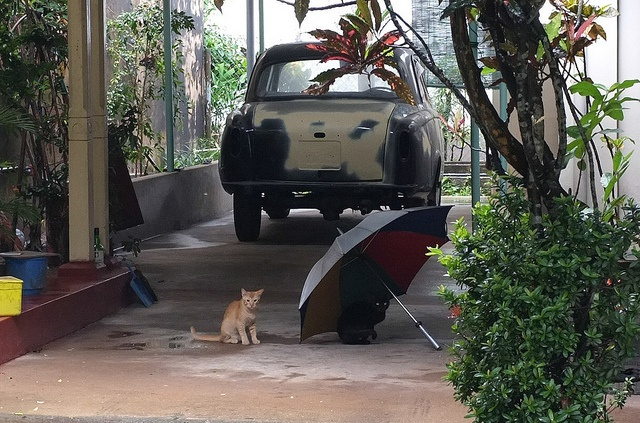Describe the objects in this image and their specific colors. I can see potted plant in darkgreen, black, and gray tones, car in darkgreen, black, gray, darkgray, and white tones, umbrella in darkgreen, black, and gray tones, cat in darkgreen, gray, and darkgray tones, and cat in darkgreen, black, and gray tones in this image. 